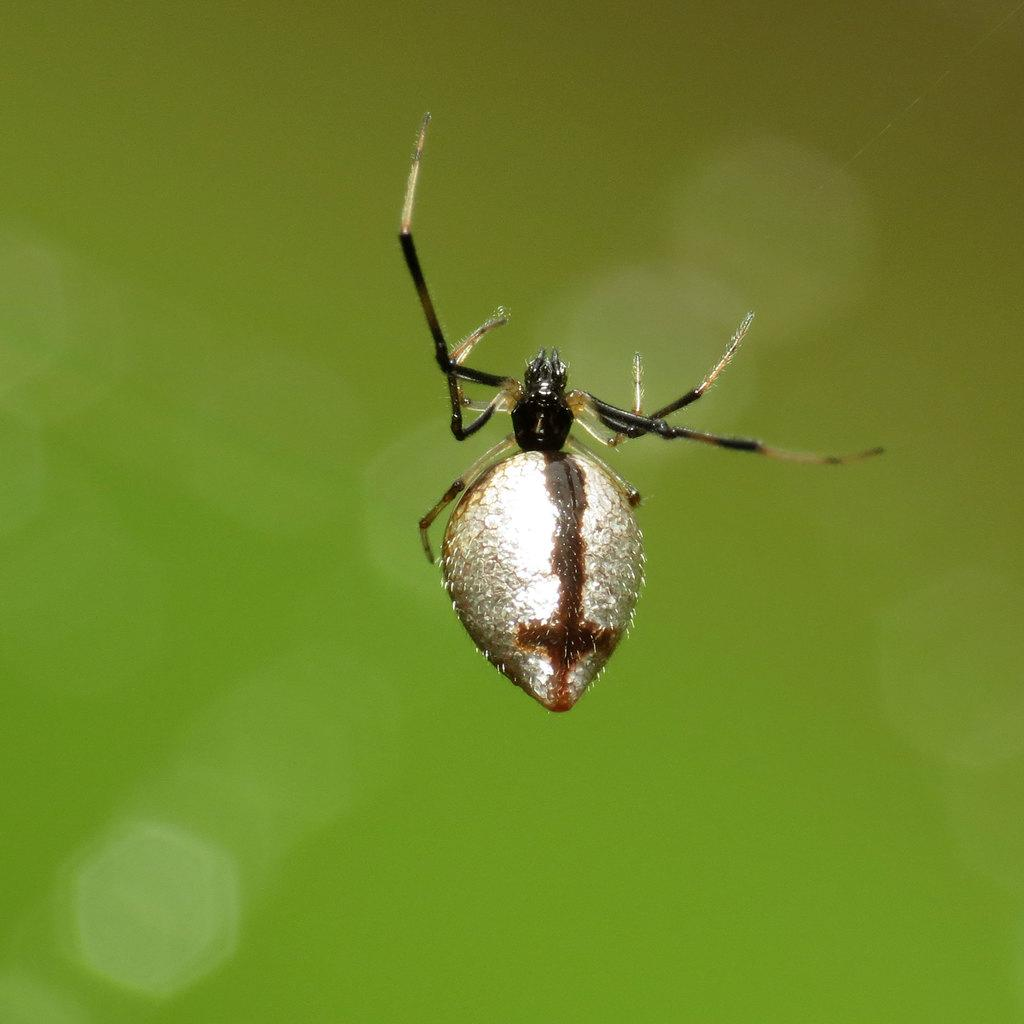What can be observed about the background of the image? The background portion of the picture is blurred, and the background color is green. Can you describe any living organisms present in the image? Yes, there is an insect visible in the picture. How many children are playing in the image? There are no children present in the image; it only features a blurred green background and an insect. 